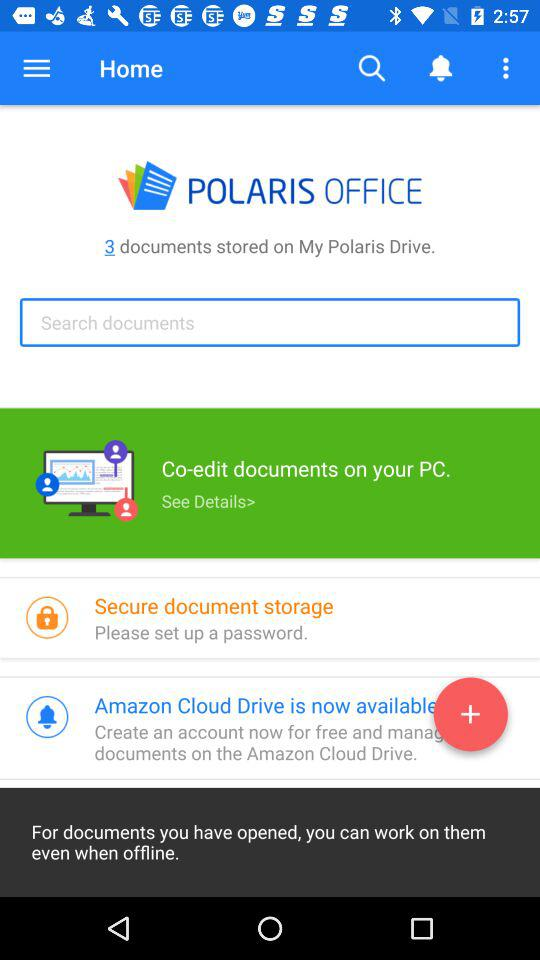How many documents are stored on the Polaris Drive?
Answer the question using a single word or phrase. 3 